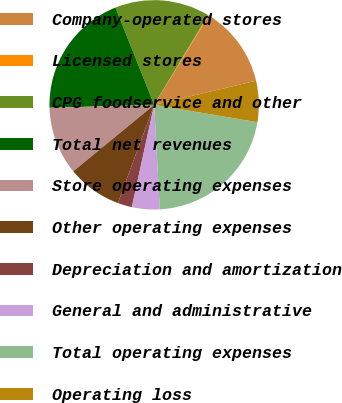Convert chart. <chart><loc_0><loc_0><loc_500><loc_500><pie_chart><fcel>Company-operated stores<fcel>Licensed stores<fcel>CPG foodservice and other<fcel>Total net revenues<fcel>Store operating expenses<fcel>Other operating expenses<fcel>Depreciation and amortization<fcel>General and administrative<fcel>Total operating expenses<fcel>Operating loss<nl><fcel>12.56%<fcel>0.14%<fcel>14.63%<fcel>19.42%<fcel>10.49%<fcel>8.42%<fcel>2.21%<fcel>4.28%<fcel>21.49%<fcel>6.35%<nl></chart> 